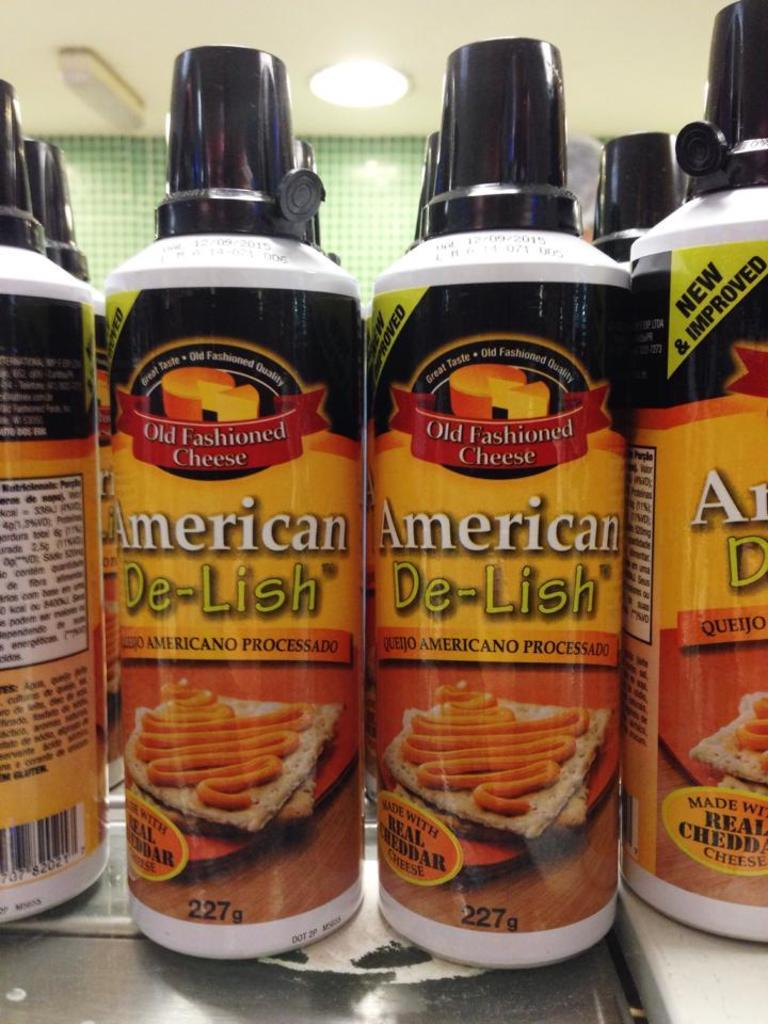What objects are located in the center of the image? There are bottles in the center of the image. What can be seen on the bottles? There is text written on the bottles. What color is the wall in the background of the image? The wall in the background of the image is green. How many lights are visible at the top of the image? There are three lights on the top of the image. What type of eggs are being compared in the image? There are no eggs present in the image, so there is no comparison being made. 